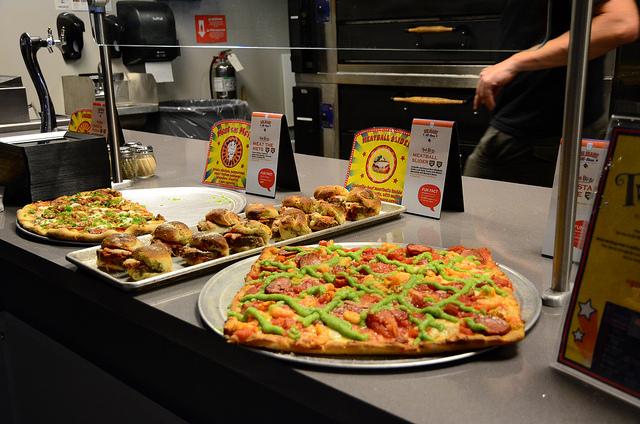Is this in a restaurant?
Write a very short answer. Yes. What size is the pizza?
Quick response, please. Large. How many pizzas?
Be succinct. 2. What kind of food is this?
Keep it brief. Pizza. Has the food been eaten?
Write a very short answer. No. 